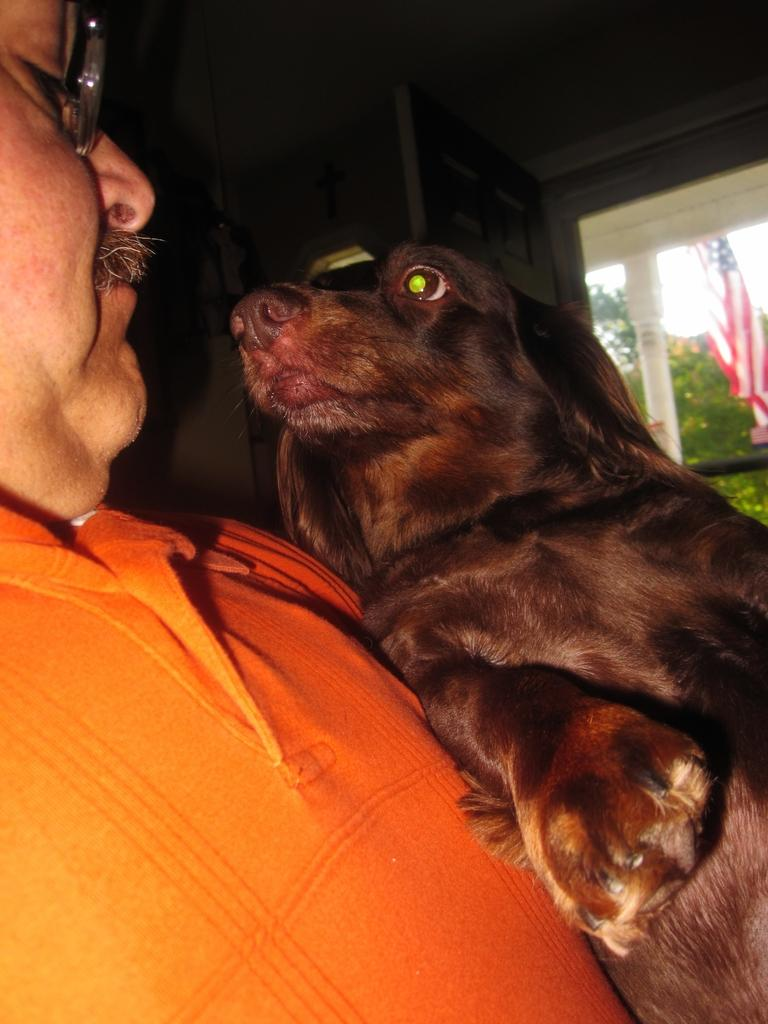What is the main subject of the image? The main subject of the image is a man. What is the man wearing? The man is wearing an orange t-shirt. What is the man doing in the image? The man is holding a dog. What can be seen in the background of the image? There is a wall, a tree, and a flag in the background of the image. What type of friction is present between the man and the dog in the image? There is no mention of friction in the image, as the man is holding the dog without any indication of resistance or force. 